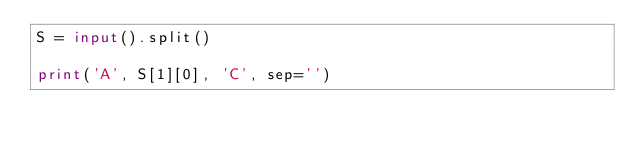<code> <loc_0><loc_0><loc_500><loc_500><_Python_>S = input().split()

print('A', S[1][0], 'C', sep='')
</code> 